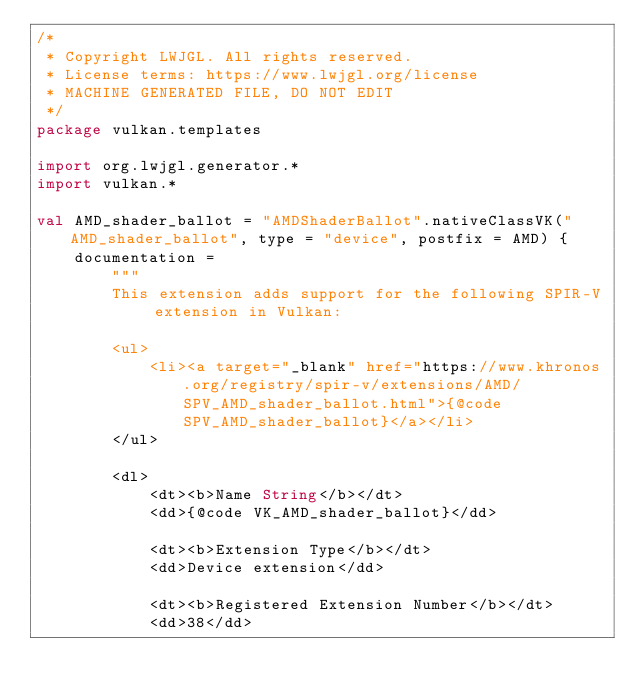Convert code to text. <code><loc_0><loc_0><loc_500><loc_500><_Kotlin_>/*
 * Copyright LWJGL. All rights reserved.
 * License terms: https://www.lwjgl.org/license
 * MACHINE GENERATED FILE, DO NOT EDIT
 */
package vulkan.templates

import org.lwjgl.generator.*
import vulkan.*

val AMD_shader_ballot = "AMDShaderBallot".nativeClassVK("AMD_shader_ballot", type = "device", postfix = AMD) {
    documentation =
        """
        This extension adds support for the following SPIR-V extension in Vulkan:

        <ul>
            <li><a target="_blank" href="https://www.khronos.org/registry/spir-v/extensions/AMD/SPV_AMD_shader_ballot.html">{@code SPV_AMD_shader_ballot}</a></li>
        </ul>

        <dl>
            <dt><b>Name String</b></dt>
            <dd>{@code VK_AMD_shader_ballot}</dd>

            <dt><b>Extension Type</b></dt>
            <dd>Device extension</dd>

            <dt><b>Registered Extension Number</b></dt>
            <dd>38</dd>
</code> 